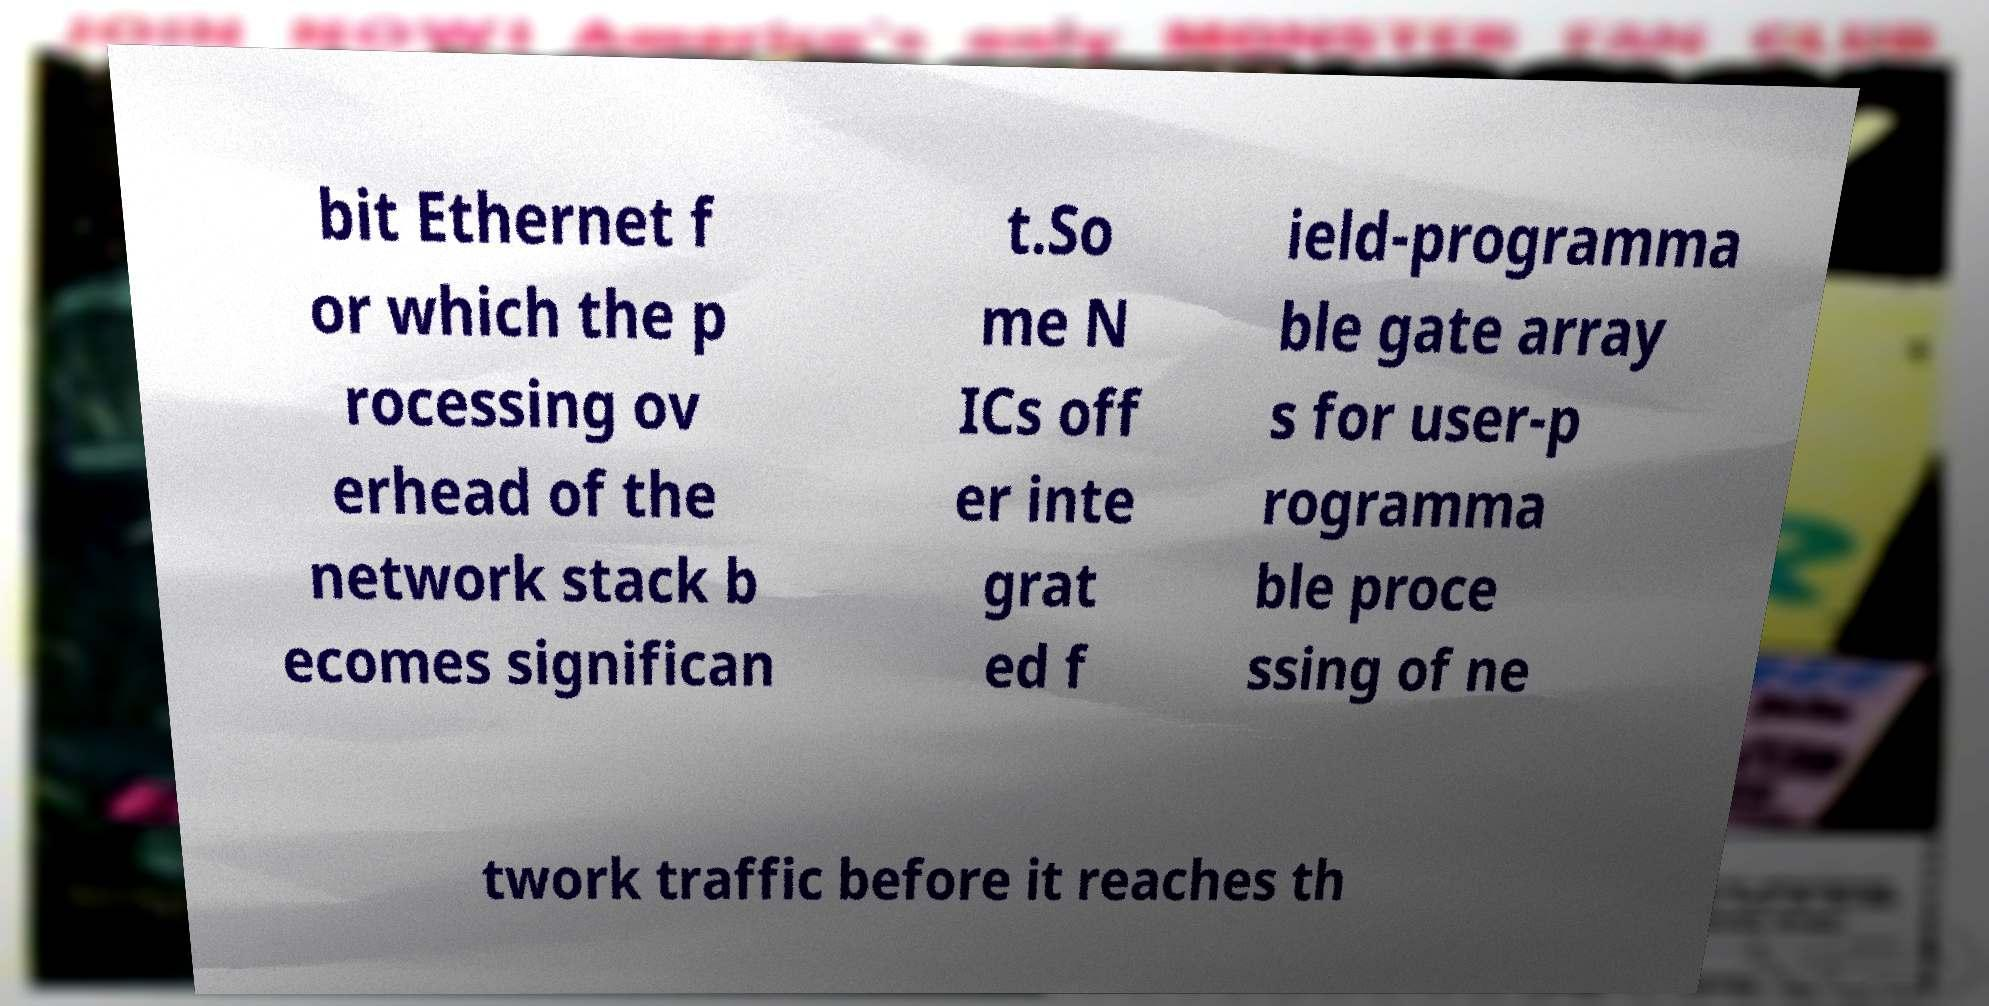Please identify and transcribe the text found in this image. bit Ethernet f or which the p rocessing ov erhead of the network stack b ecomes significan t.So me N ICs off er inte grat ed f ield-programma ble gate array s for user-p rogramma ble proce ssing of ne twork traffic before it reaches th 